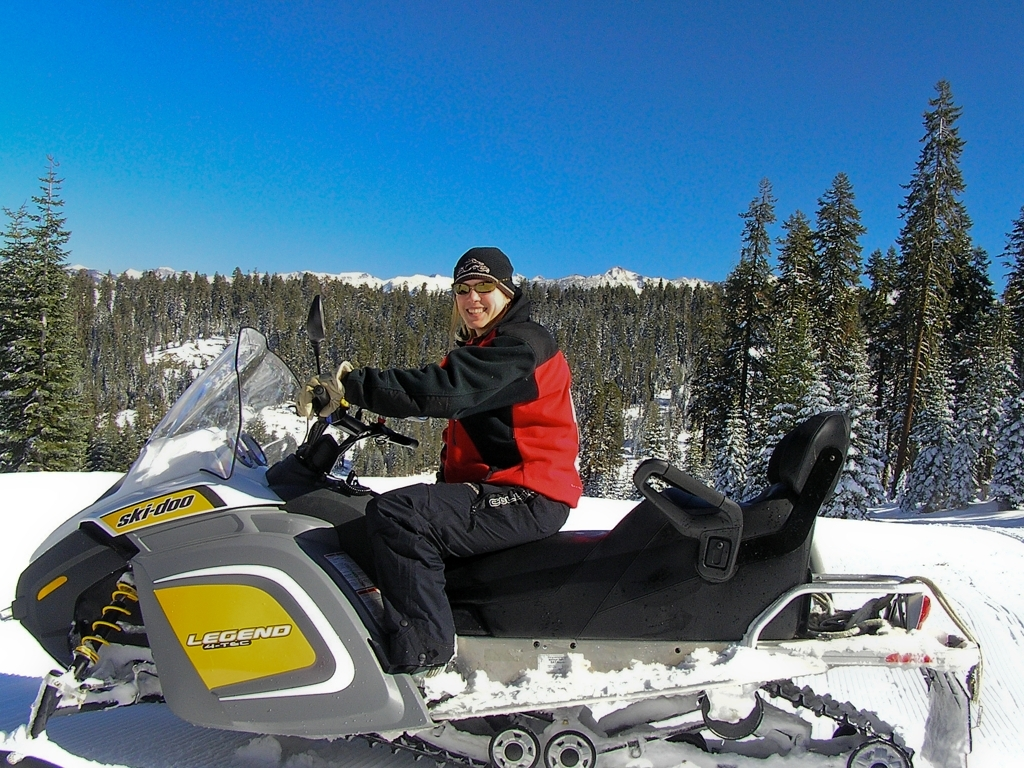Is the clarity of the image high? The image is quite clear, showcasing a person on a snowmobile with a well-defined snowy landscape in the background. The details of the snowmobile, the person's attire, and the surrounding trees are sharp, indicating high-resolution and good focus, which is welcome for capturing the vibrancy and beauty of winter activities. 